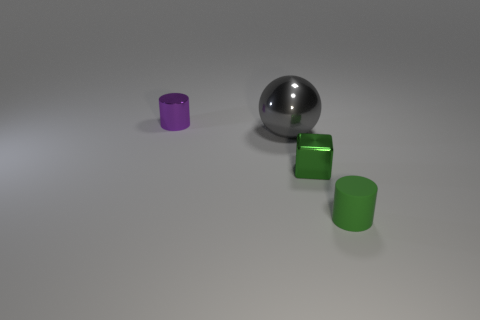Is there any other thing that is the same size as the gray metal sphere?
Provide a short and direct response. No. What number of things are either shiny things on the right side of the big gray object or yellow rubber blocks?
Offer a terse response. 1. Is the size of the green matte cylinder the same as the cylinder that is on the left side of the tiny green matte cylinder?
Ensure brevity in your answer.  Yes. How many small objects are purple shiny cylinders or green things?
Offer a terse response. 3. What is the shape of the small purple metal object?
Offer a terse response. Cylinder. Are there any large red things that have the same material as the big gray sphere?
Your answer should be very brief. No. Is the number of purple metallic balls greater than the number of small green things?
Keep it short and to the point. No. Are the large gray sphere and the small block made of the same material?
Make the answer very short. Yes. What number of rubber things are either blue cylinders or cubes?
Give a very brief answer. 0. What color is the rubber cylinder that is the same size as the purple shiny cylinder?
Your response must be concise. Green. 